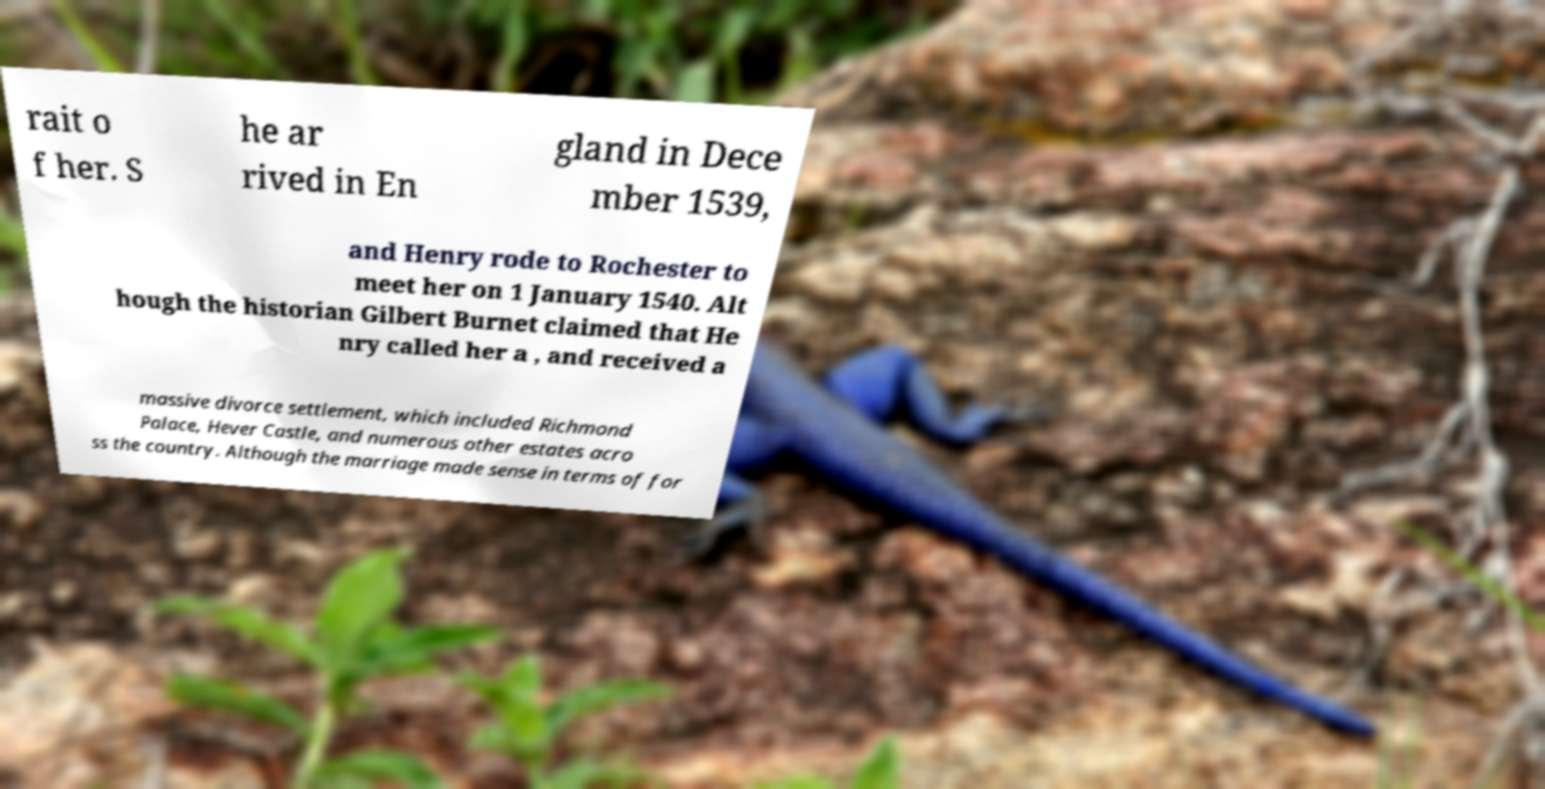Can you read and provide the text displayed in the image?This photo seems to have some interesting text. Can you extract and type it out for me? rait o f her. S he ar rived in En gland in Dece mber 1539, and Henry rode to Rochester to meet her on 1 January 1540. Alt hough the historian Gilbert Burnet claimed that He nry called her a , and received a massive divorce settlement, which included Richmond Palace, Hever Castle, and numerous other estates acro ss the country. Although the marriage made sense in terms of for 